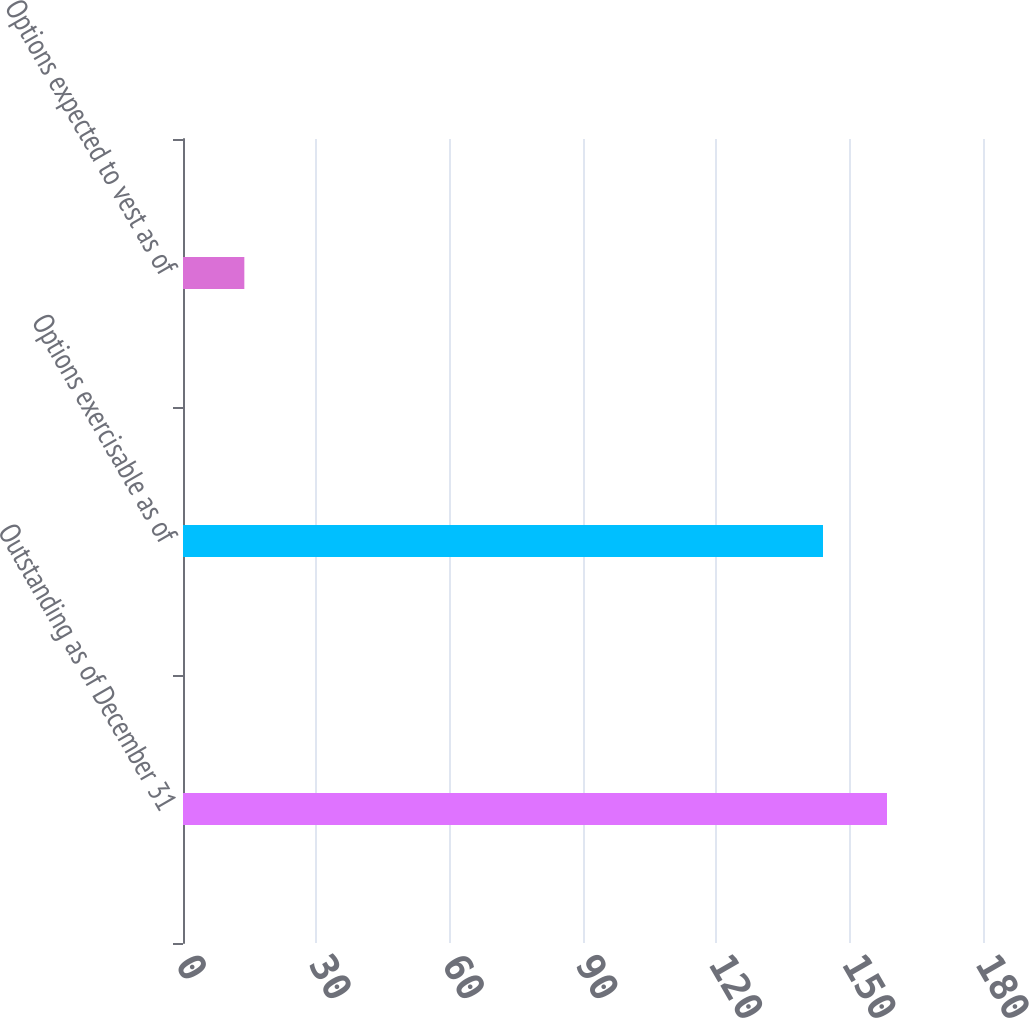<chart> <loc_0><loc_0><loc_500><loc_500><bar_chart><fcel>Outstanding as of December 31<fcel>Options exercisable as of<fcel>Options expected to vest as of<nl><fcel>158.4<fcel>144<fcel>13.8<nl></chart> 